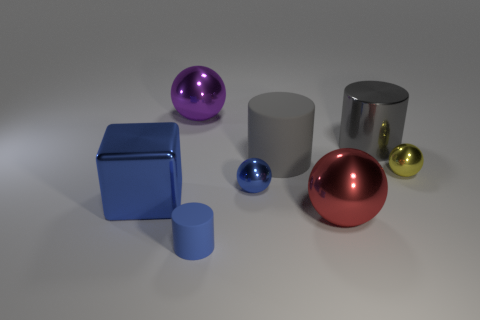There is a blue thing that is the same shape as the big gray matte object; what is its size?
Offer a terse response. Small. Are there an equal number of big gray rubber cylinders and red cubes?
Offer a very short reply. No. What number of objects are purple metallic objects or big metallic cubes?
Give a very brief answer. 2. There is a large blue cube that is in front of the tiny yellow shiny sphere; what number of big blue metallic cubes are behind it?
Give a very brief answer. 0. How many other things are the same size as the purple sphere?
Provide a short and direct response. 4. What size is the sphere that is the same color as the small cylinder?
Your response must be concise. Small. There is a matte object that is in front of the yellow metallic object; does it have the same shape as the small yellow thing?
Keep it short and to the point. No. There is a big purple object left of the tiny blue cylinder; what is its material?
Keep it short and to the point. Metal. There is a large rubber thing that is the same color as the metal cylinder; what shape is it?
Provide a succinct answer. Cylinder. Are there any large gray things that have the same material as the yellow object?
Make the answer very short. Yes. 